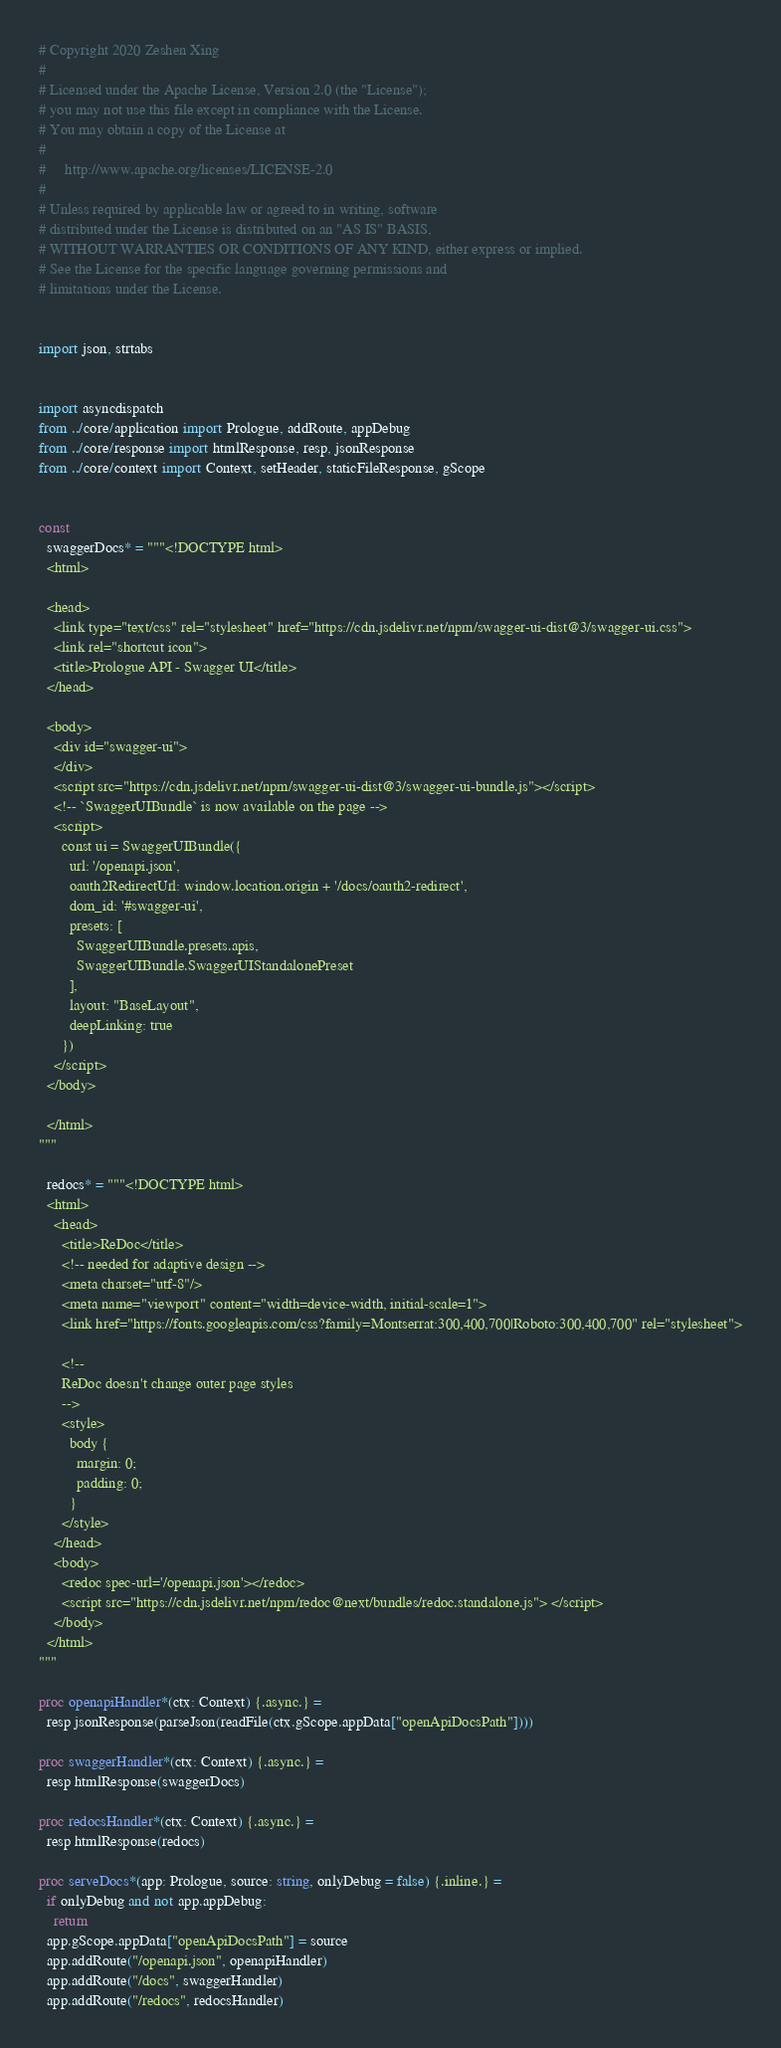<code> <loc_0><loc_0><loc_500><loc_500><_Nim_># Copyright 2020 Zeshen Xing
# 
# Licensed under the Apache License, Version 2.0 (the "License");
# you may not use this file except in compliance with the License.
# You may obtain a copy of the License at
# 
#     http://www.apache.org/licenses/LICENSE-2.0
# 
# Unless required by applicable law or agreed to in writing, software
# distributed under the License is distributed on an "AS IS" BASIS,
# WITHOUT WARRANTIES OR CONDITIONS OF ANY KIND, either express or implied.
# See the License for the specific language governing permissions and
# limitations under the License.


import json, strtabs


import asyncdispatch
from ../core/application import Prologue, addRoute, appDebug
from ../core/response import htmlResponse, resp, jsonResponse
from ../core/context import Context, setHeader, staticFileResponse, gScope


const
  swaggerDocs* = """<!DOCTYPE html>
  <html>
  
  <head>
    <link type="text/css" rel="stylesheet" href="https://cdn.jsdelivr.net/npm/swagger-ui-dist@3/swagger-ui.css">
    <link rel="shortcut icon">
    <title>Prologue API - Swagger UI</title>
  </head>
  
  <body>
    <div id="swagger-ui">
    </div>
    <script src="https://cdn.jsdelivr.net/npm/swagger-ui-dist@3/swagger-ui-bundle.js"></script>
    <!-- `SwaggerUIBundle` is now available on the page -->
    <script>
      const ui = SwaggerUIBundle({
        url: '/openapi.json',
        oauth2RedirectUrl: window.location.origin + '/docs/oauth2-redirect',
        dom_id: '#swagger-ui',
        presets: [
          SwaggerUIBundle.presets.apis,
          SwaggerUIBundle.SwaggerUIStandalonePreset
        ],
        layout: "BaseLayout",
        deepLinking: true
      })
    </script>
  </body>
  
  </html>
"""

  redocs* = """<!DOCTYPE html>
  <html>
    <head>
      <title>ReDoc</title>
      <!-- needed for adaptive design -->
      <meta charset="utf-8"/>
      <meta name="viewport" content="width=device-width, initial-scale=1">
      <link href="https://fonts.googleapis.com/css?family=Montserrat:300,400,700|Roboto:300,400,700" rel="stylesheet">
  
      <!--
      ReDoc doesn't change outer page styles
      -->
      <style>
        body {
          margin: 0;
          padding: 0;
        }
      </style>
    </head>
    <body>
      <redoc spec-url='/openapi.json'></redoc>
      <script src="https://cdn.jsdelivr.net/npm/redoc@next/bundles/redoc.standalone.js"> </script>
    </body>
  </html> 
"""

proc openapiHandler*(ctx: Context) {.async.} =
  resp jsonResponse(parseJson(readFile(ctx.gScope.appData["openApiDocsPath"])))

proc swaggerHandler*(ctx: Context) {.async.} =
  resp htmlResponse(swaggerDocs)

proc redocsHandler*(ctx: Context) {.async.} =
  resp htmlResponse(redocs)

proc serveDocs*(app: Prologue, source: string, onlyDebug = false) {.inline.} =
  if onlyDebug and not app.appDebug:
    return
  app.gScope.appData["openApiDocsPath"] = source
  app.addRoute("/openapi.json", openapiHandler)
  app.addRoute("/docs", swaggerHandler)
  app.addRoute("/redocs", redocsHandler)
</code> 